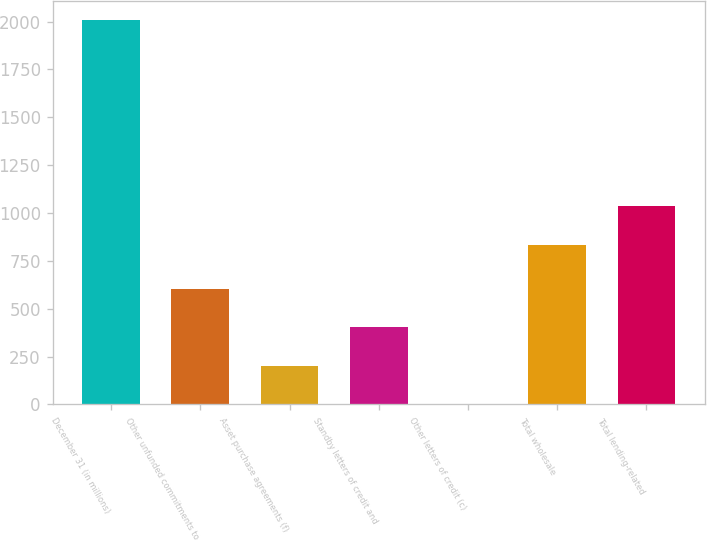Convert chart. <chart><loc_0><loc_0><loc_500><loc_500><bar_chart><fcel>December 31 (in millions)<fcel>Other unfunded commitments to<fcel>Asset purchase agreements (f)<fcel>Standby letters of credit and<fcel>Other letters of credit (c)<fcel>Total wholesale<fcel>Total lending-related<nl><fcel>2007<fcel>602.8<fcel>201.6<fcel>402.2<fcel>1<fcel>835<fcel>1035.6<nl></chart> 